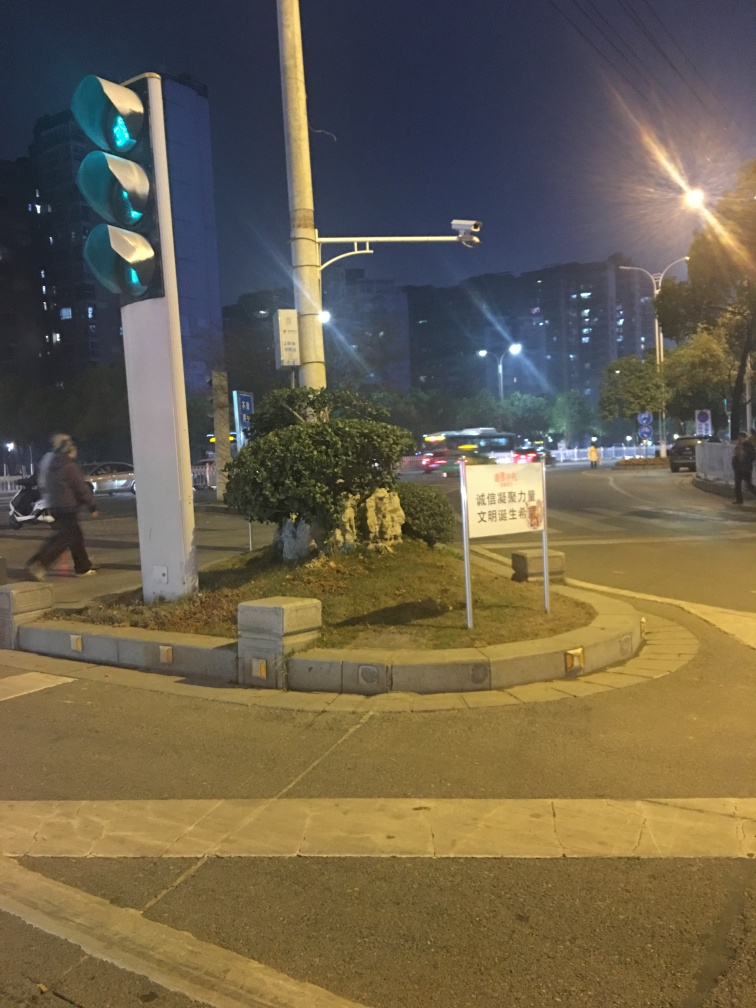Can you describe the lighting in the image and what time of day it might represent? The image showcases artificial lighting—from street lamps and traffic lights—suggesting it is taken during night-time. The sky is dark, and the artificial light sources cast multiple shadows, adding to the night-time ambiance. 